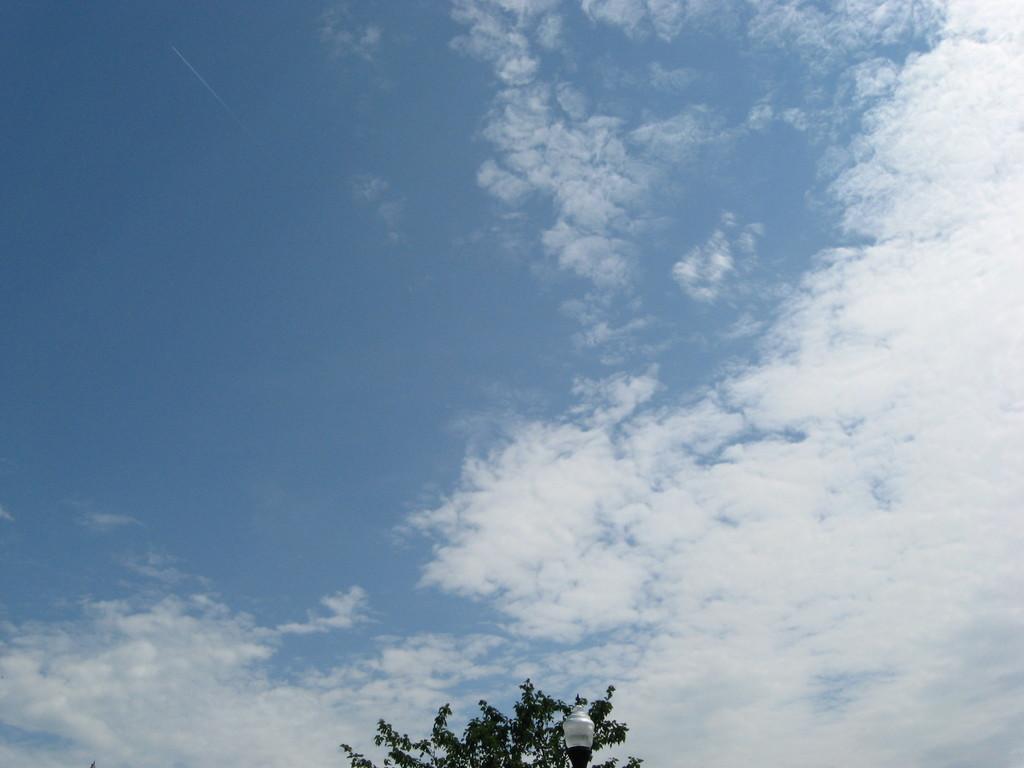In one or two sentences, can you explain what this image depicts? In this picture I can see the leaves and a light pole on the bottom side of this picture. In the background I can see the clear sky. 